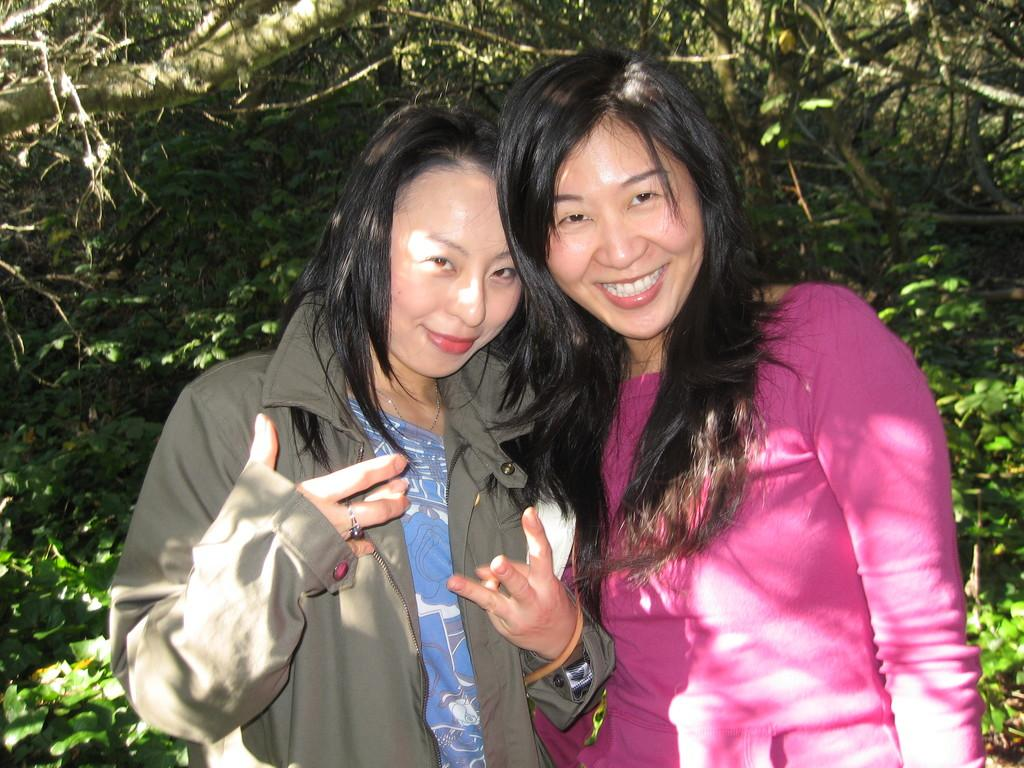How many people are present in the image? There are two people in the image. What is the facial expression of the people in the image? The people are smiling. What can be seen in the background of the image? There are trees in the background of the image. What type of ticket is being distributed by the people in the image? There is no ticket or distribution activity present in the image; it only features two people smiling. Where is the sink located in the image? There is no sink present in the image. 